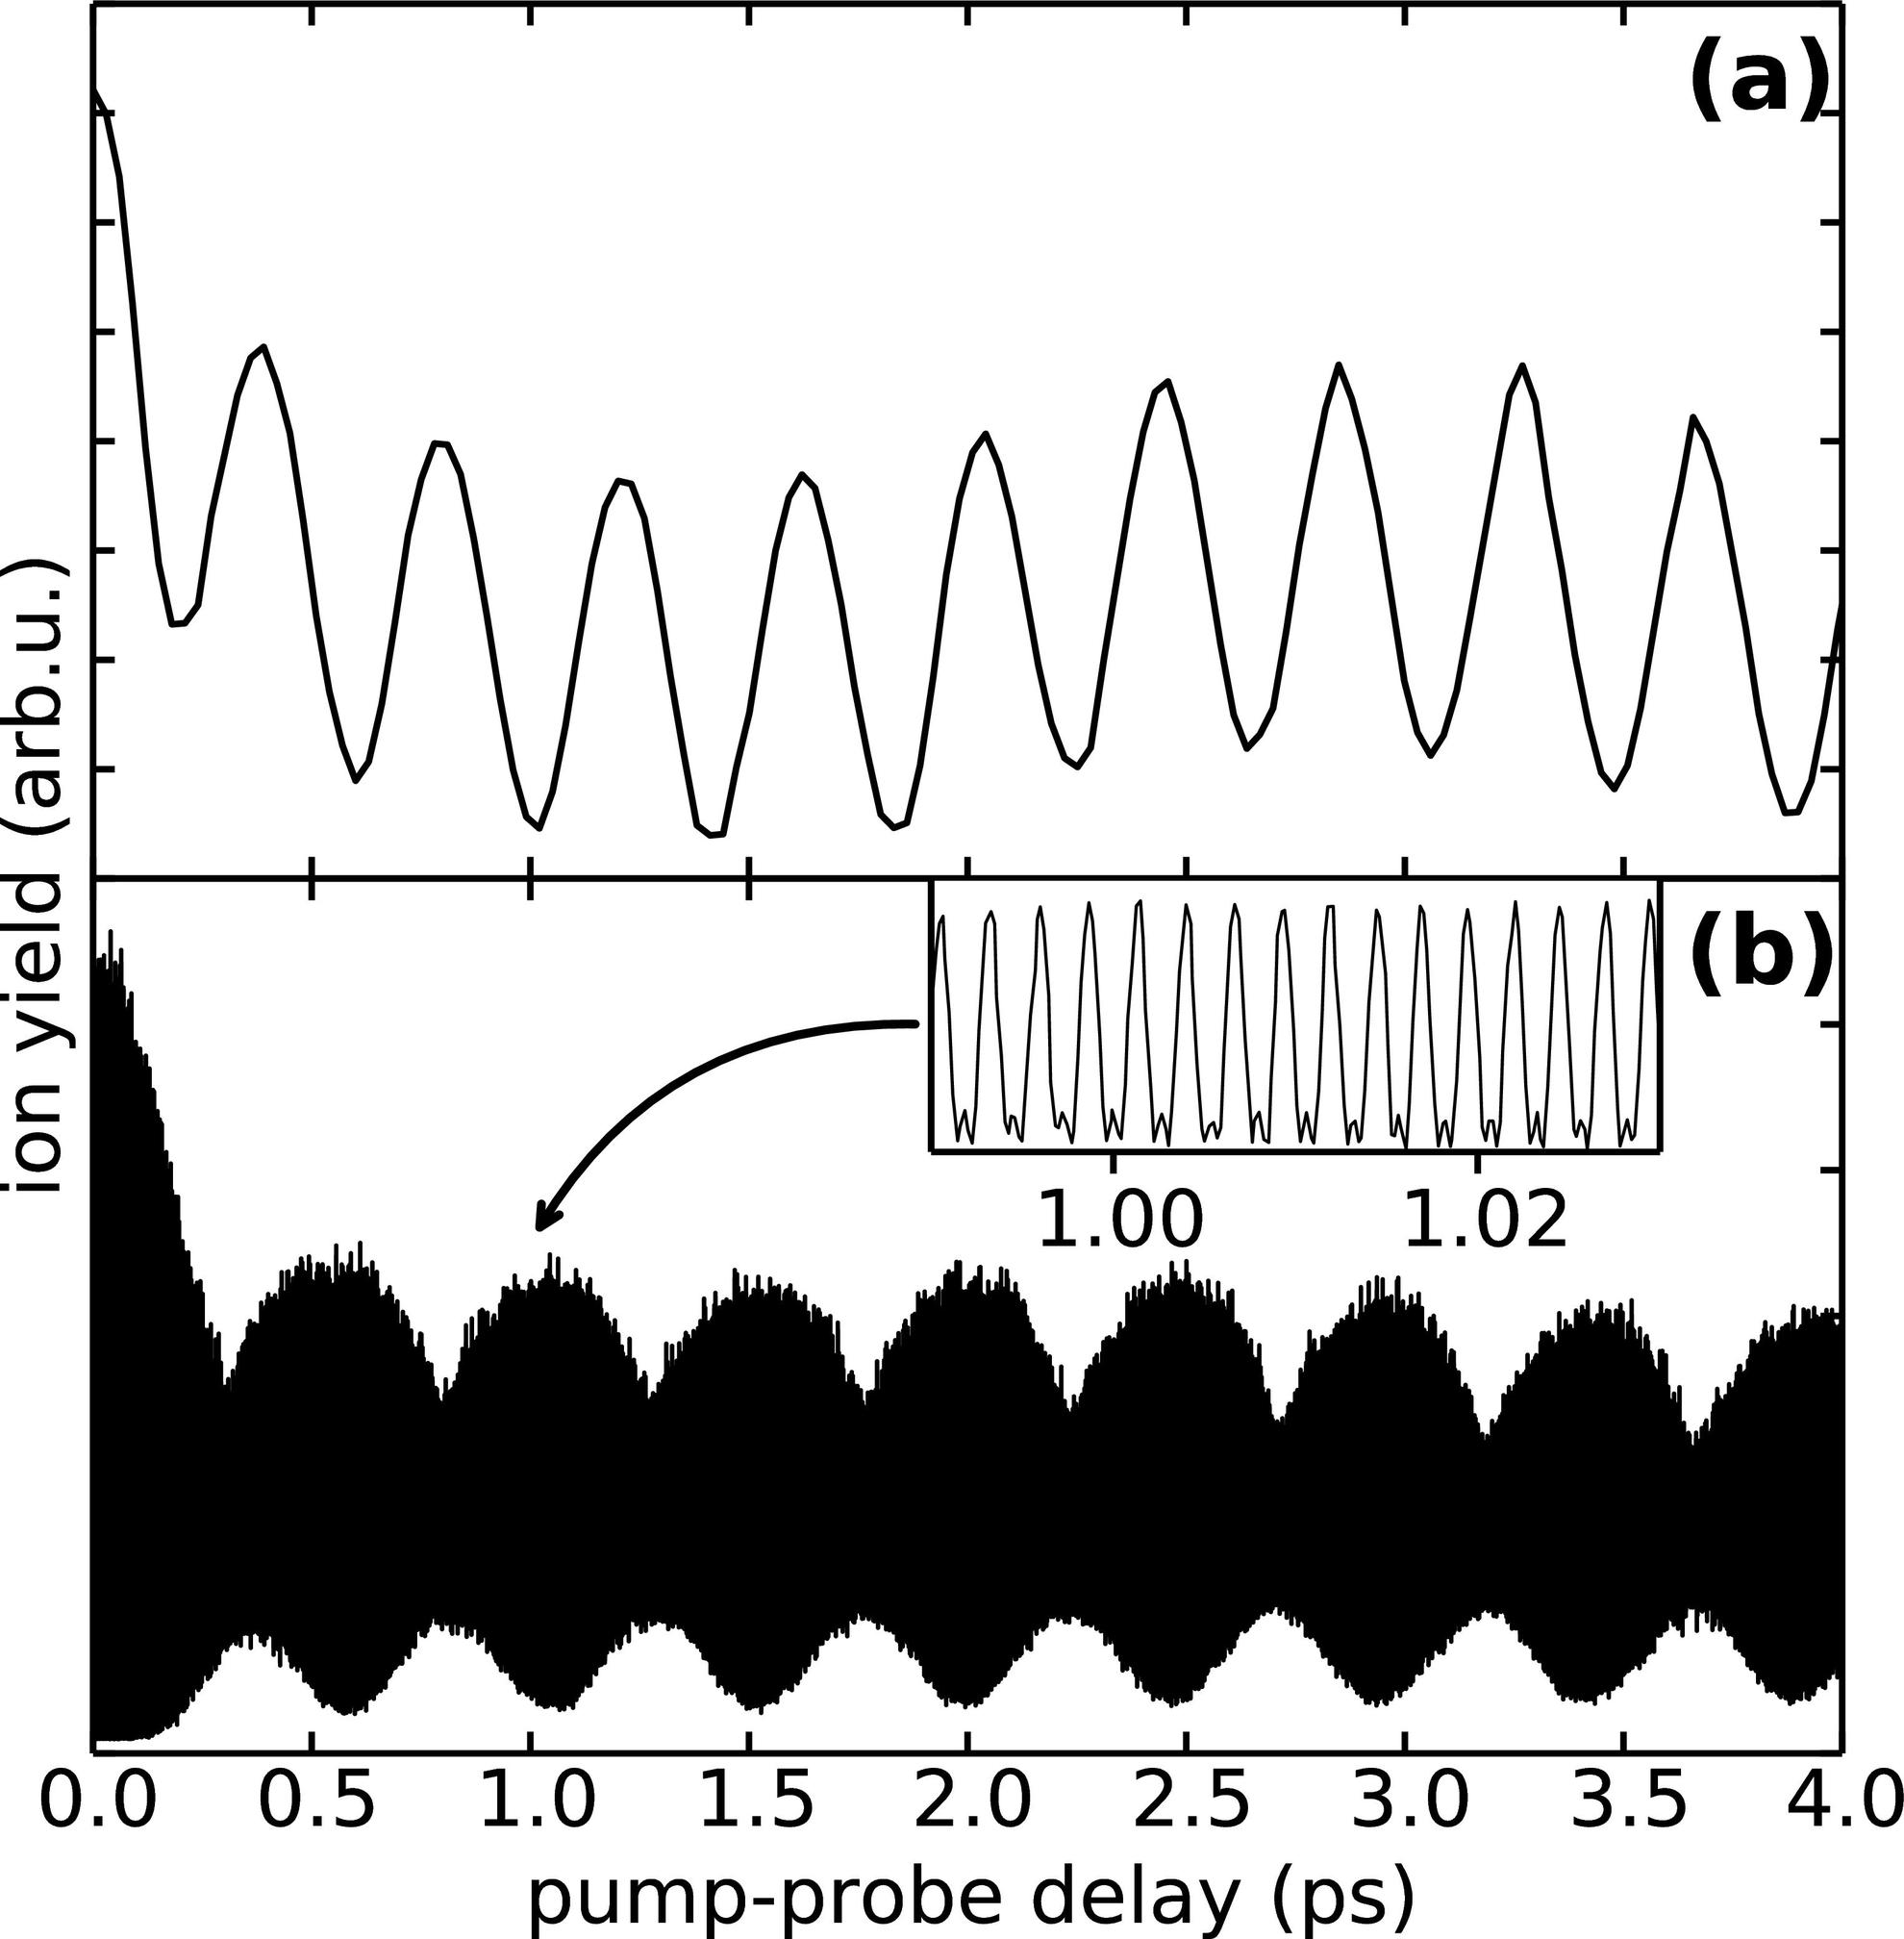How does the information in the inset in panel (b) contribute to the overall findings of the experiment? The inset in panel (b) focuses on a narrow time window to accentuate specific features of the oscillation pattern that might be overlooked in the broader graph. This detailed view can help confirm the presence of underlying mechanisms like quantum beats or coupling effects, playing a crucial role in validating theoretical models or guiding further experimental adjustments. 